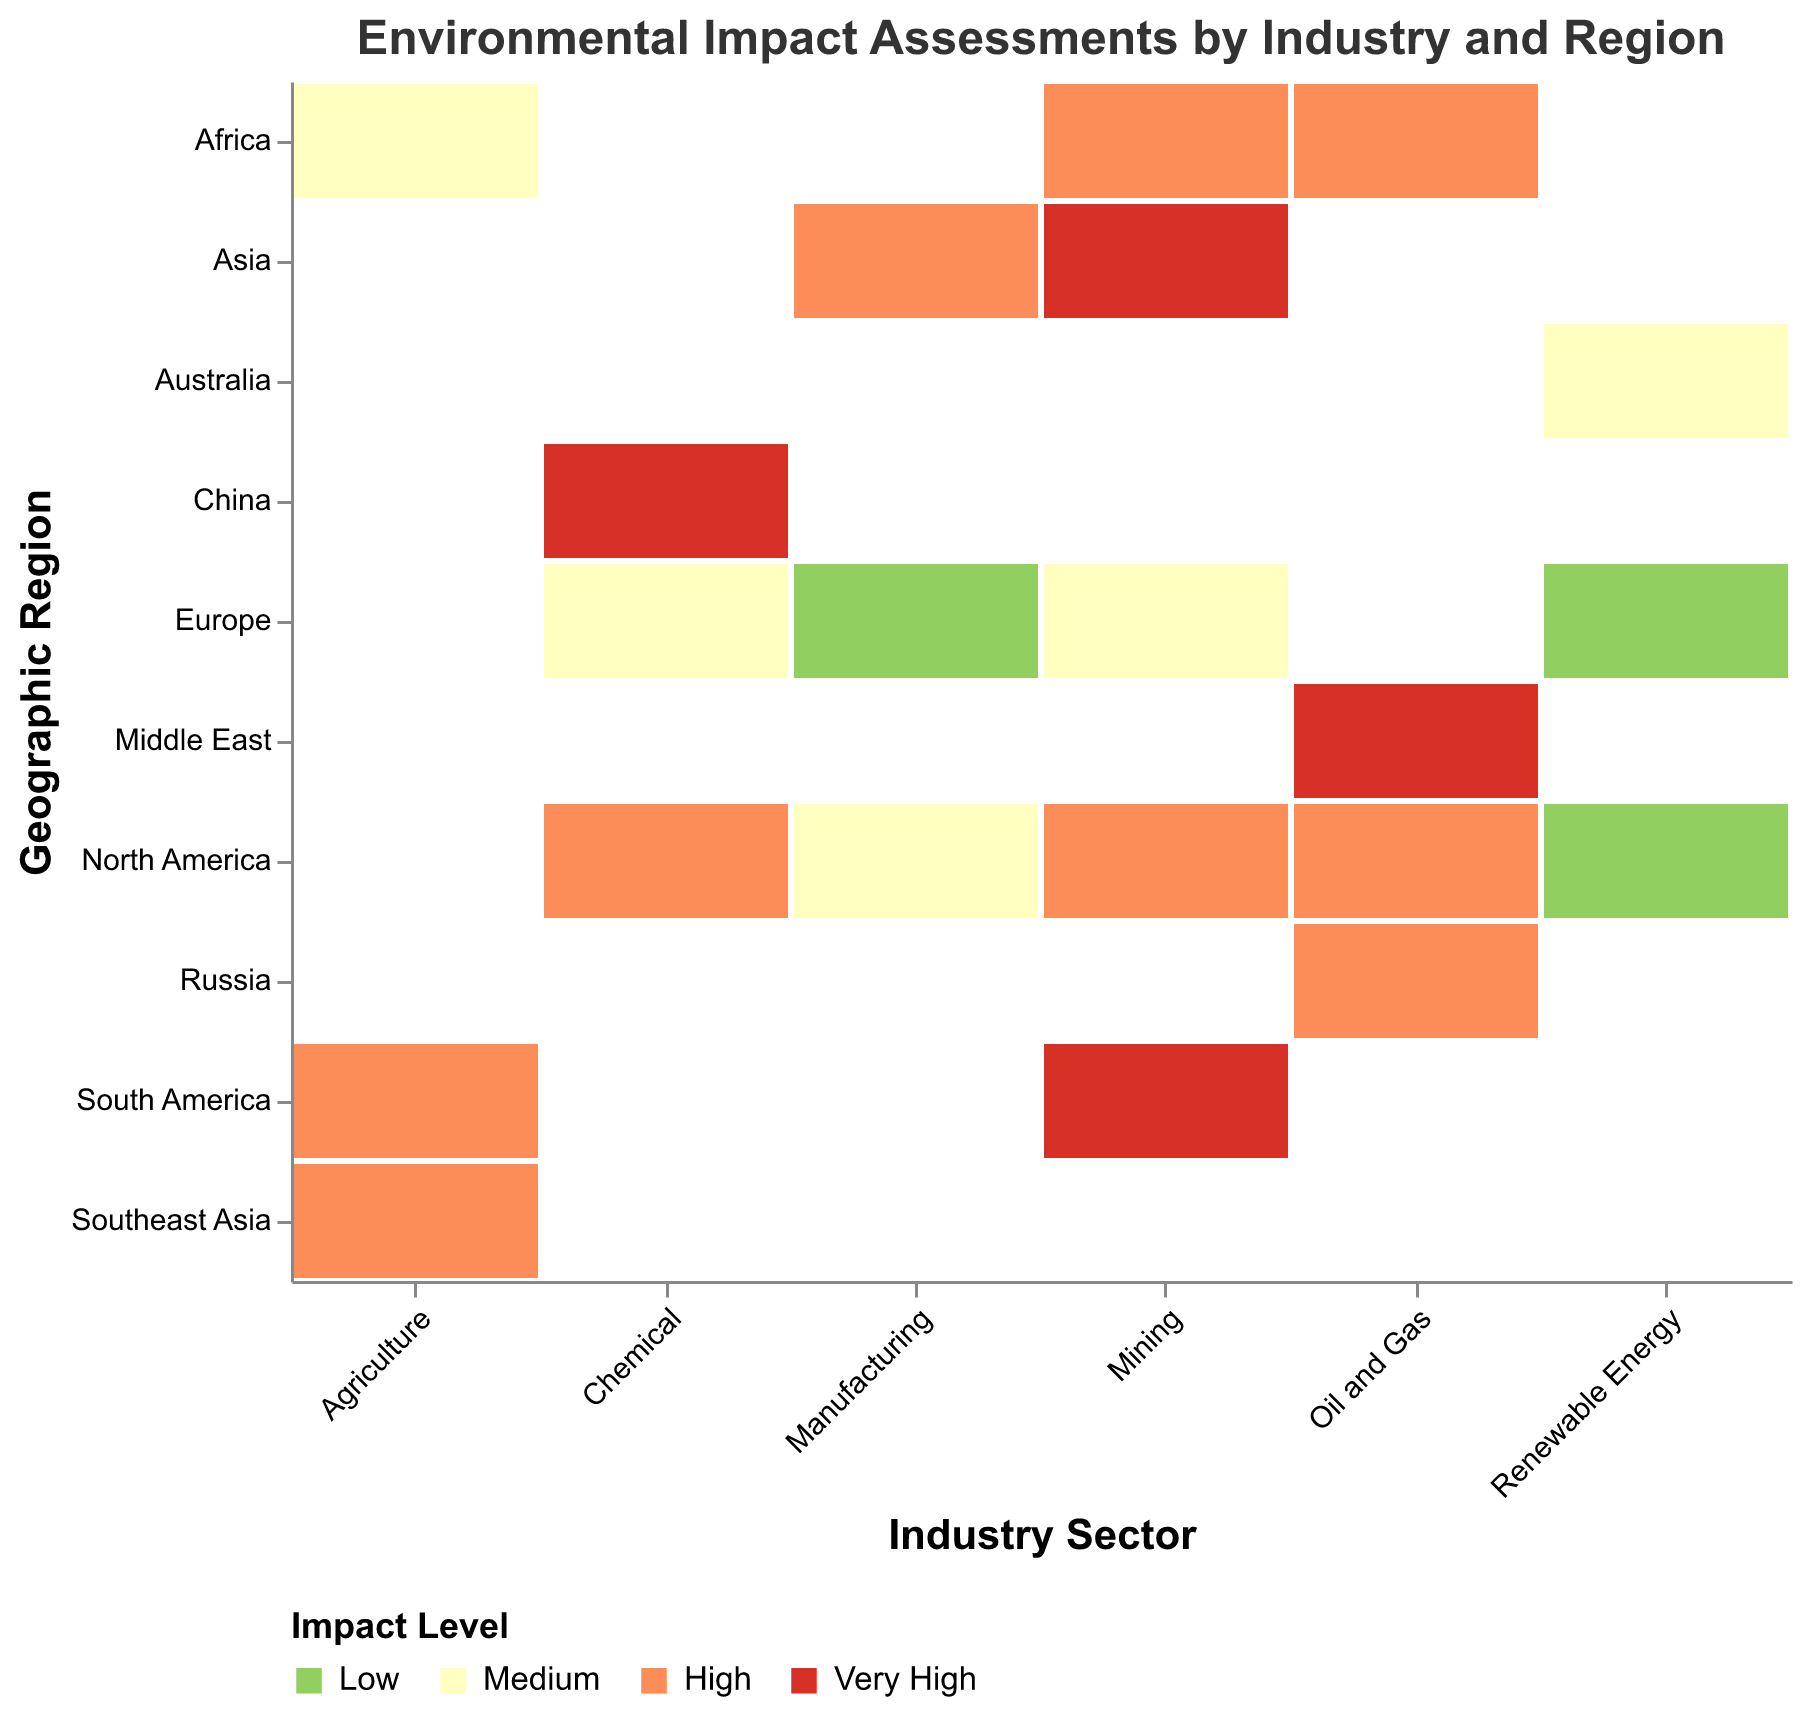What is the visual title of the mosaic plot? The title of the plot is usually displayed at the top of the figure. It is designed to give viewers a clear idea about the data being presented. Here, the title reads "Environmental Impact Assessments by Industry and Region".
Answer: Environmental Impact Assessments by Industry and Region What are the different Impact Levels represented in the plot? The plot displays different colors to represent various Impact Levels. By looking at the legend, we can see the levels are "Low", "Medium", "High", and "Very High".
Answer: Low, Medium, High, Very High Which geographic region has the highest impact for the Mining sector? To determine this, find the Mining sector on the x-axis and then look at the colors in the corresponding column. 'Very High' corresponds to dark red. South America and Asia are colored dark red, indicating they have the highest impact levels.
Answer: South America and Asia How does the impact level of Renewable Energy in Europe compare to that in North America? For this, identify the Renewable Energy sector. In that column, note the colors for Europe and North America. Europe is represented by the color for "Low" impact (green), whereas North America also shows "Low" (green).
Answer: Equal (Low) What is the most common Impact Level for the Oil and Gas sector across all regions? Check the Oil and Gas column and count the frequency of each color. The most frequently occurring color represents the most common impact level. "High" (orange) appears most often in the Oil and Gas category.
Answer: High Which sector has the least environmental impact in most of its regions? Find the sectors and observe their color distribution. The Renewable Energy sector mostly shows "Low" impact (green) compared to others.
Answer: Renewable Energy How many regions report a "Very High" impact level for any sector? Look across the entire plot and count the number of dark red rectangles, corresponding to a "Very High" impact level. There are four dark red rectangles.
Answer: Four Does the Manufacturing sector in Europe have a higher or lower impact than in North America? Compare the Manufacturing sector's column. Europe is represented by "Low" impact (green), while North America shows "Medium" impact (yellow).
Answer: Lower What impact level is represented in the Middle East for the Oil and Gas sector? Locate the Oil and Gas sector and follow the column to find the Middle East row. The color in this intersection is dark red, indicating a "Very High" impact.
Answer: Very High Are there any sectors with "Medium" impact in China? Identify the column for each sector and check if any sector aligned with China shows the yellow color for "Medium". The Chemical sector in China has a "Very High" (dark red) impact and there is no yellow for "Medium".
Answer: No 